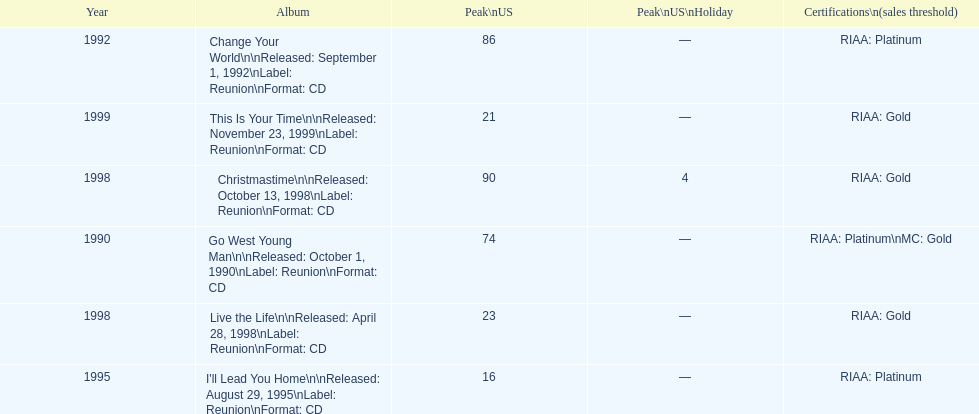What year comes after 1995? 1998. Could you parse the entire table? {'header': ['Year', 'Album', 'Peak\\nUS', 'Peak\\nUS\\nHoliday', 'Certifications\\n(sales threshold)'], 'rows': [['1992', 'Change Your World\\n\\nReleased: September 1, 1992\\nLabel: Reunion\\nFormat: CD', '86', '—', 'RIAA: Platinum'], ['1999', 'This Is Your Time\\n\\nReleased: November 23, 1999\\nLabel: Reunion\\nFormat: CD', '21', '—', 'RIAA: Gold'], ['1998', 'Christmastime\\n\\nReleased: October 13, 1998\\nLabel: Reunion\\nFormat: CD', '90', '4', 'RIAA: Gold'], ['1990', 'Go West Young Man\\n\\nReleased: October 1, 1990\\nLabel: Reunion\\nFormat: CD', '74', '—', 'RIAA: Platinum\\nMC: Gold'], ['1998', 'Live the Life\\n\\nReleased: April 28, 1998\\nLabel: Reunion\\nFormat: CD', '23', '—', 'RIAA: Gold'], ['1995', "I'll Lead You Home\\n\\nReleased: August 29, 1995\\nLabel: Reunion\\nFormat: CD", '16', '—', 'RIAA: Platinum']]} 